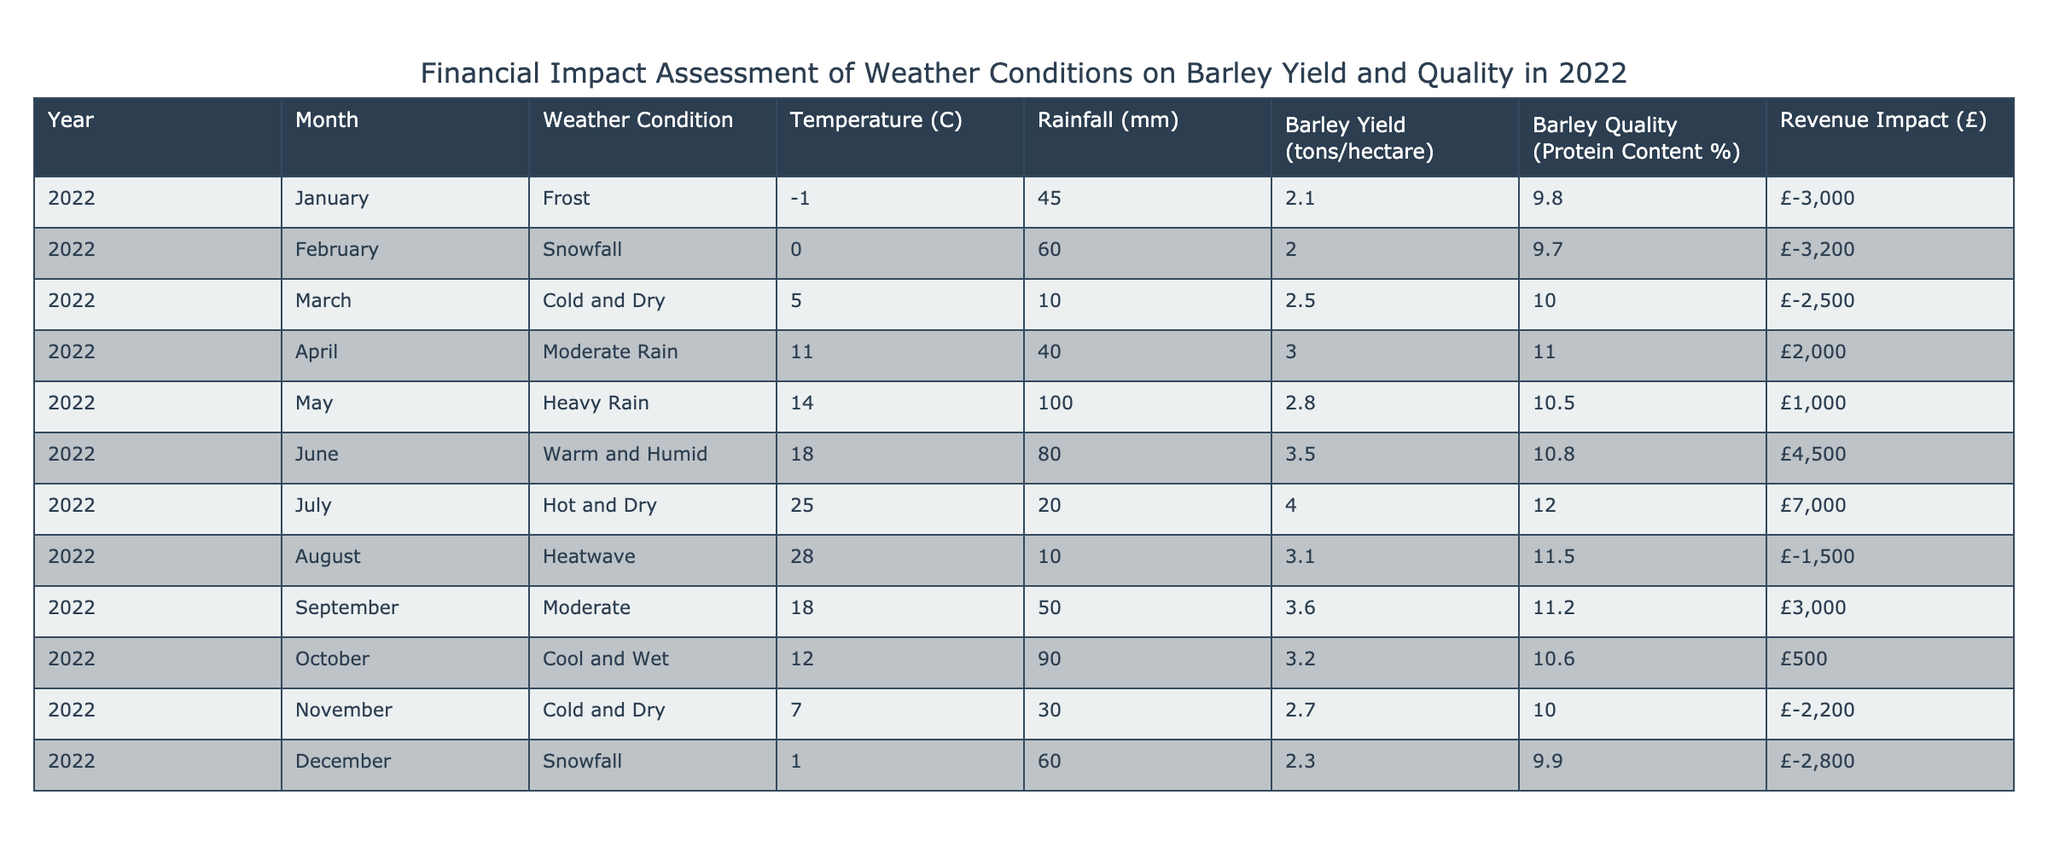What was the barley yield in July 2022? According to the table, the barley yield for July 2022 is listed as 4.0 tons/hectare.
Answer: 4.0 tons/hectare What was the revenue impact in March 2022? The revenue impact for March 2022 is indicated as -2500, which can be read directly from the table.
Answer: -2500 Is the protein content higher in August than in April? From the table, the protein content in April is 11.0%, while in August it is 11.5%. Therefore, August's protein content is higher than April's.
Answer: Yes What is the total revenue impact for the months with heavy rainfall (May and October)? The revenue impact for May is 1000 and for October is 500. Summing these gives 1000 + 500 = 1500.
Answer: 1500 Which month had the highest barley yield and what was that yield? From the table, July 2022 had the highest barley yield, recorded at 4.0 tons/hectare.
Answer: 4.0 tons/hectare Was there any event in December that had a positive revenue impact? The revenue impact in December is -2800, indicating a loss instead of a positive impact. Therefore, there was no positive impact in December.
Answer: No What was the average protein content for the months with a revenue impact greater than zero? The months with a revenue impact greater than zero are April (11.0%), June (10.8%), July (12.0%), and September (11.2%). Calculating the average gives (11.0 + 10.8 + 12.0 + 11.2) / 4 = 11.25%.
Answer: 11.25% What was the weather condition in June and how did it impact the barley yield? The weather condition in June is recorded as "Warm and Humid," and this resulted in a barley yield of 3.5 tons/hectare, which is one of the higher yields for the year.
Answer: Warm and Humid; 3.5 tons/hectare During which month did the lowest yield occur and what was the yield value? The lowest barley yield occurred in February with a yield of 2.0 tons/hectare. This is supported by the data from the table.
Answer: 2.0 tons/hectare 